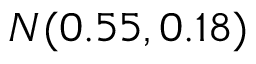Convert formula to latex. <formula><loc_0><loc_0><loc_500><loc_500>N ( 0 . 5 5 , 0 . 1 8 )</formula> 